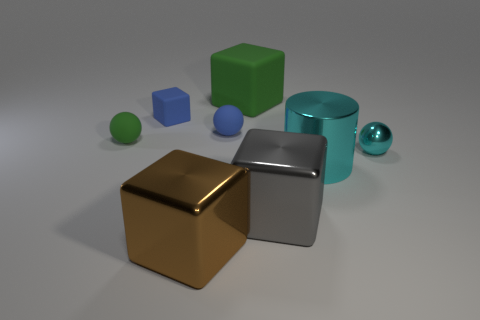How many spheres are either tiny objects or brown metallic objects?
Your answer should be compact. 3. How many objects are both behind the cylinder and in front of the big green matte cube?
Ensure brevity in your answer.  4. Is the size of the shiny cylinder the same as the green matte thing behind the small green object?
Offer a very short reply. Yes. There is a matte cube that is right of the small matte ball that is right of the tiny green rubber object; are there any shiny objects on the right side of it?
Your response must be concise. Yes. What is the tiny blue sphere that is in front of the green rubber thing that is right of the big brown block made of?
Offer a very short reply. Rubber. The thing that is both in front of the small cyan object and behind the large gray thing is made of what material?
Make the answer very short. Metal. Are there any other small things of the same shape as the tiny cyan shiny object?
Offer a terse response. Yes. Are there any tiny things that are to the right of the metal thing to the left of the gray metal object?
Offer a very short reply. Yes. How many tiny yellow cylinders have the same material as the large cyan thing?
Offer a very short reply. 0. Is there a big gray rubber block?
Your response must be concise. No. 